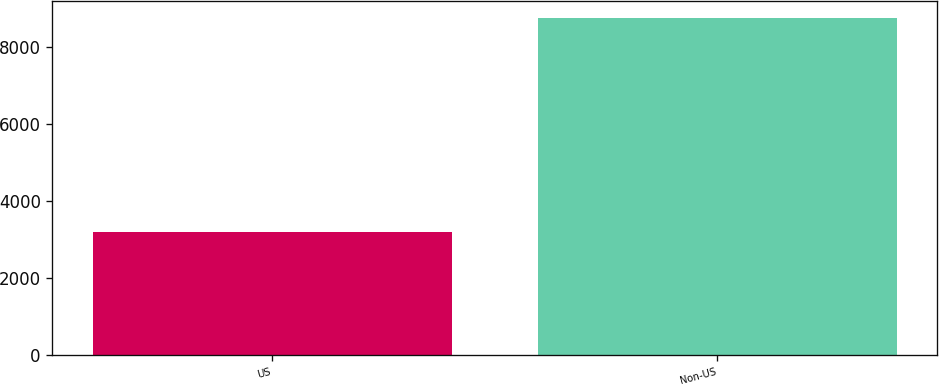<chart> <loc_0><loc_0><loc_500><loc_500><bar_chart><fcel>US<fcel>Non-US<nl><fcel>3192<fcel>8741<nl></chart> 